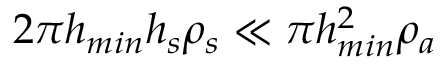Convert formula to latex. <formula><loc_0><loc_0><loc_500><loc_500>2 \pi h _ { \min } h _ { s } \rho _ { s } \ll \pi h _ { \min } ^ { 2 } \rho _ { a }</formula> 